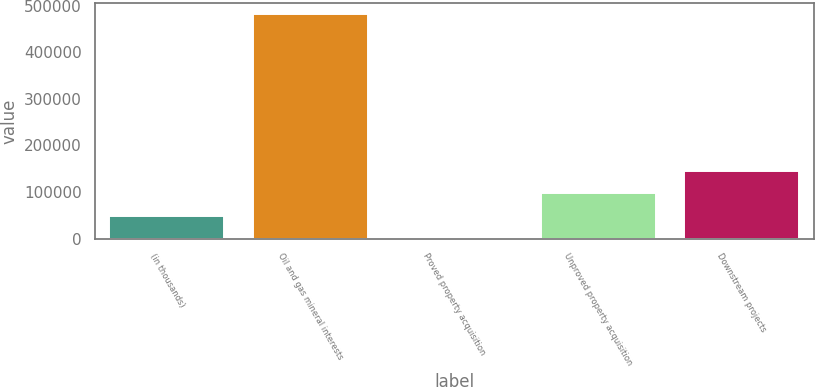<chart> <loc_0><loc_0><loc_500><loc_500><bar_chart><fcel>(in thousands)<fcel>Oil and gas mineral interests<fcel>Proved property acquisition<fcel>Unproved property acquisition<fcel>Downstream projects<nl><fcel>49288.2<fcel>481236<fcel>1294<fcel>97282.4<fcel>145277<nl></chart> 